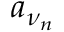Convert formula to latex. <formula><loc_0><loc_0><loc_500><loc_500>a _ { \nu _ { n } }</formula> 